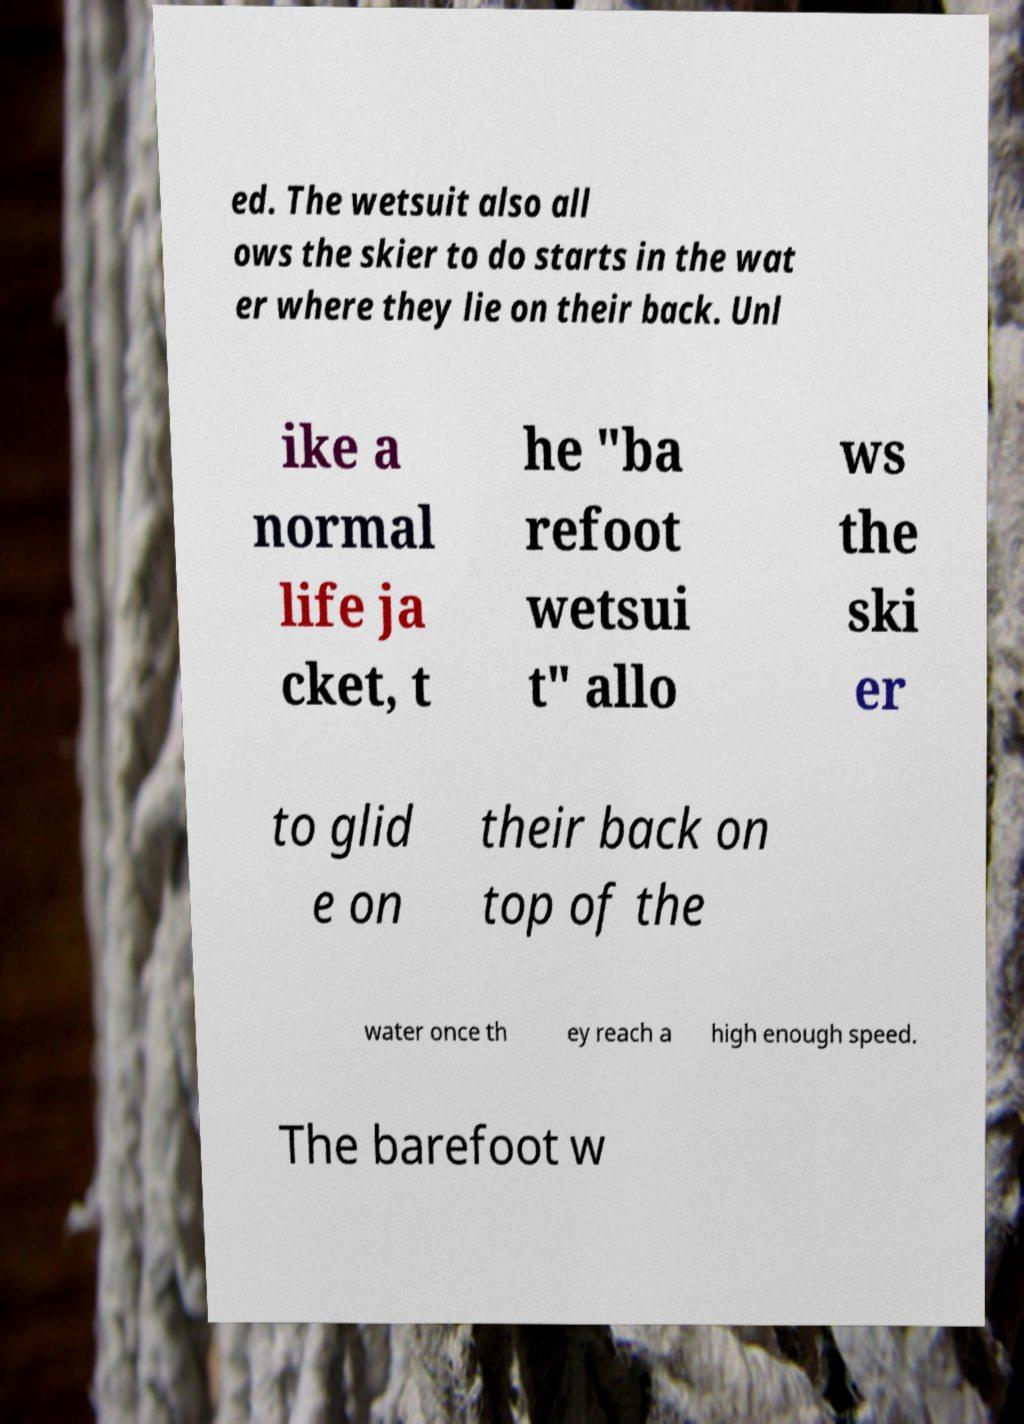What messages or text are displayed in this image? I need them in a readable, typed format. ed. The wetsuit also all ows the skier to do starts in the wat er where they lie on their back. Unl ike a normal life ja cket, t he "ba refoot wetsui t" allo ws the ski er to glid e on their back on top of the water once th ey reach a high enough speed. The barefoot w 